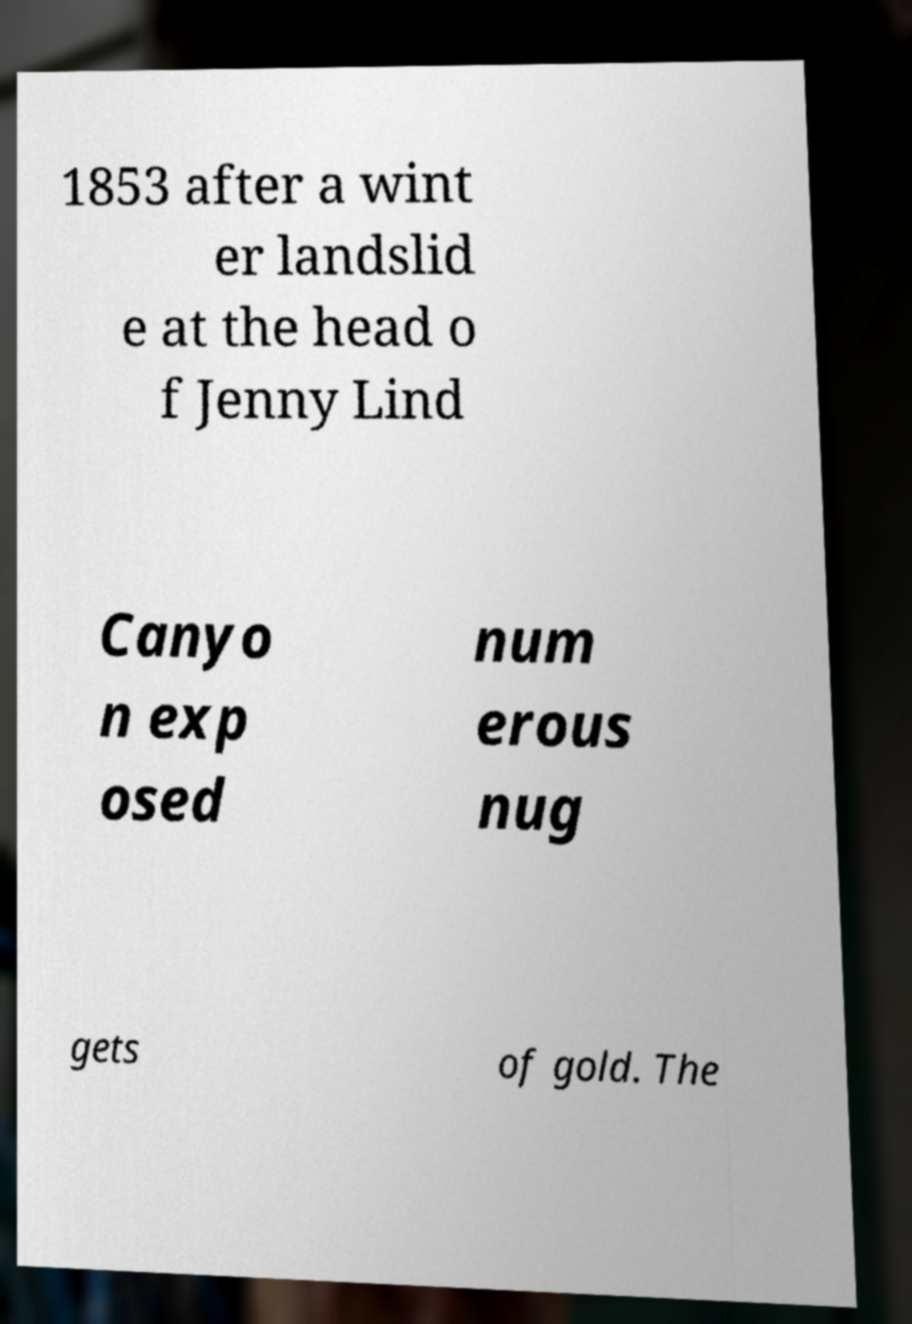Could you assist in decoding the text presented in this image and type it out clearly? 1853 after a wint er landslid e at the head o f Jenny Lind Canyo n exp osed num erous nug gets of gold. The 